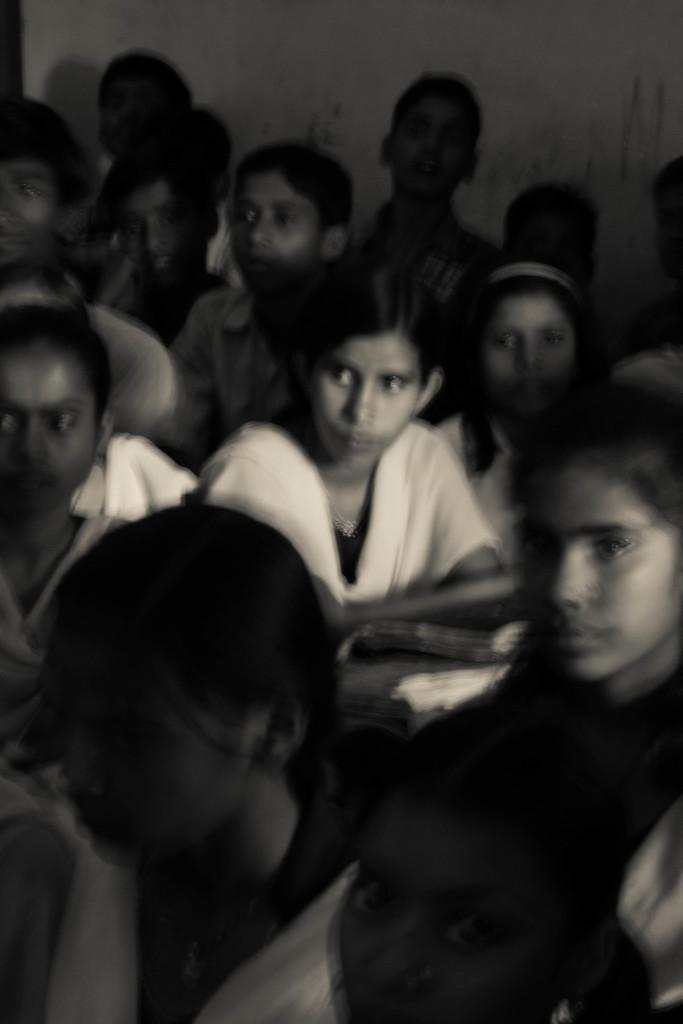What is the color scheme of the image? The image is black and white. Can you describe the subjects in the image? There are a few people in the image. What type of structure can be seen in the image? There is a wall visible in the image. What type of sticks are being offered by the people in the image? There are no sticks present in the image, and the people are not offering anything. 